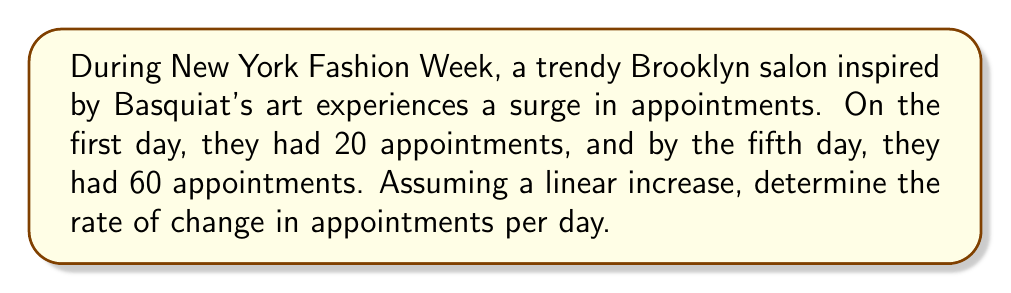Show me your answer to this math problem. To find the rate of change, we need to use the slope formula:

$$ m = \frac{y_2 - y_1}{x_2 - x_1} $$

Where:
$m$ = rate of change (slope)
$(x_1, y_1)$ = initial point (day 1, 20 appointments)
$(x_2, y_2)$ = final point (day 5, 60 appointments)

Step 1: Identify the points
$(x_1, y_1) = (1, 20)$
$(x_2, y_2) = (5, 60)$

Step 2: Plug the values into the slope formula
$$ m = \frac{60 - 20}{5 - 1} = \frac{40}{4} $$

Step 3: Simplify
$$ m = 10 $$

Therefore, the rate of change is 10 appointments per day.
Answer: 10 appointments/day 